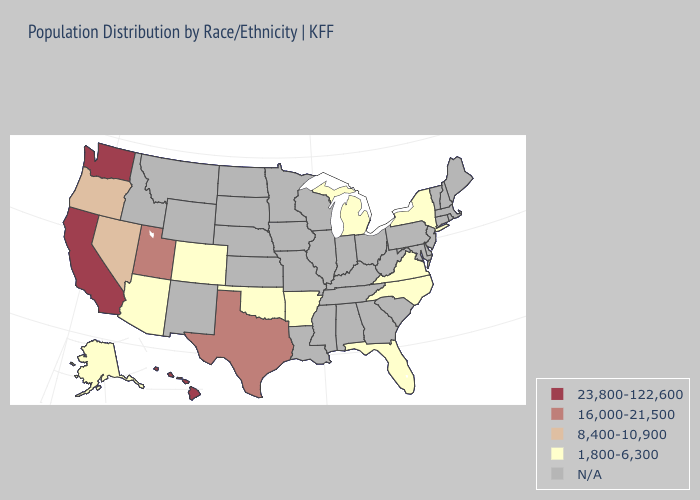What is the highest value in states that border New Jersey?
Concise answer only. 1,800-6,300. Name the states that have a value in the range 16,000-21,500?
Keep it brief. Texas, Utah. Name the states that have a value in the range N/A?
Keep it brief. Alabama, Connecticut, Delaware, Georgia, Idaho, Illinois, Indiana, Iowa, Kansas, Kentucky, Louisiana, Maine, Maryland, Massachusetts, Minnesota, Mississippi, Missouri, Montana, Nebraska, New Hampshire, New Jersey, New Mexico, North Dakota, Ohio, Pennsylvania, Rhode Island, South Carolina, South Dakota, Tennessee, Vermont, West Virginia, Wisconsin, Wyoming. What is the value of Arizona?
Give a very brief answer. 1,800-6,300. What is the value of Georgia?
Give a very brief answer. N/A. Does Hawaii have the highest value in the USA?
Keep it brief. Yes. What is the value of Pennsylvania?
Write a very short answer. N/A. What is the lowest value in the South?
Keep it brief. 1,800-6,300. Name the states that have a value in the range 1,800-6,300?
Concise answer only. Alaska, Arizona, Arkansas, Colorado, Florida, Michigan, New York, North Carolina, Oklahoma, Virginia. Name the states that have a value in the range 16,000-21,500?
Keep it brief. Texas, Utah. Name the states that have a value in the range 8,400-10,900?
Answer briefly. Nevada, Oregon. What is the value of Maine?
Short answer required. N/A. 